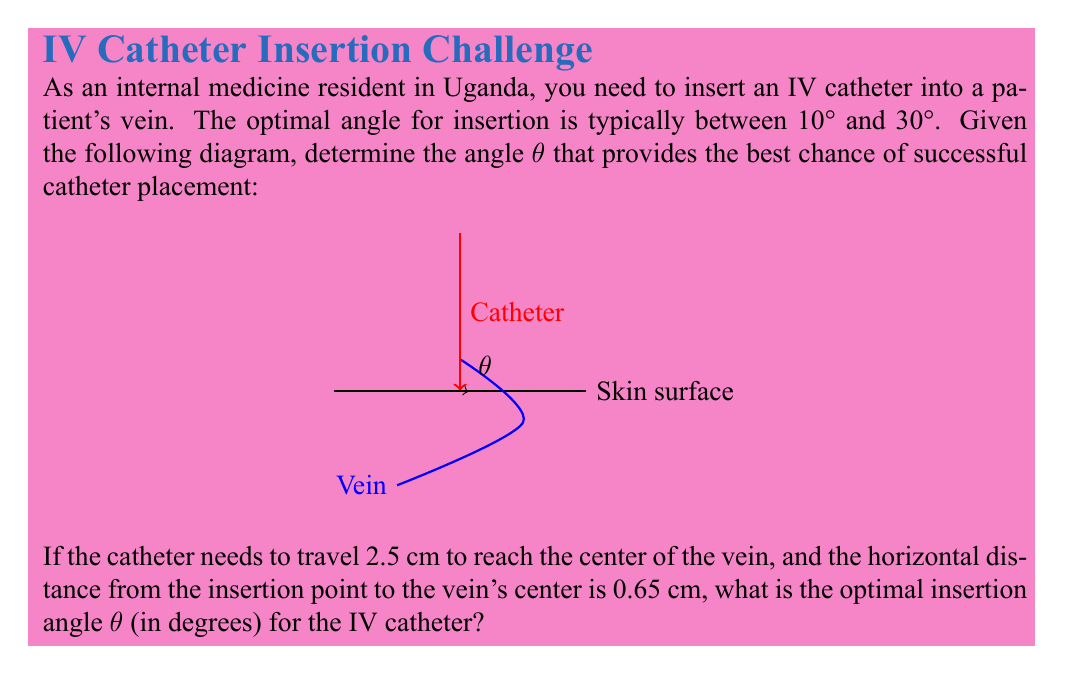Can you answer this question? To solve this problem, we'll use trigonometry:

1) We can treat the catheter's path as the hypotenuse of a right triangle, where:
   - The vertical side is the depth of the vein (2.5 cm)
   - The horizontal side is the distance to the vein's center (0.65 cm)

2) We can use the tangent function to find the angle:

   $$\tan(\theta) = \frac{\text{opposite}}{\text{adjacent}} = \frac{2.5}{0.65}$$

3) To find θ, we need to use the inverse tangent (arctan or tan^(-1)):

   $$\theta = \arctan(\frac{2.5}{0.65})$$

4) Using a calculator or computer:

   $$\theta \approx 75.38^\circ$$

5) However, we know that the optimal angle is between 10° and 30°. This calculated angle is much too steep and would likely result in the catheter puncturing through the vein.

6) To correct this, we need to subtract our calculated angle from 90°:

   $$90^\circ - 75.38^\circ \approx 14.62^\circ$$

7) This angle falls within the optimal range of 10° to 30°.

8) Rounding to the nearest degree for practical application:

   $$14.62^\circ \approx 15^\circ$$

Therefore, the optimal insertion angle for the IV catheter is approximately 15°.
Answer: 15° 